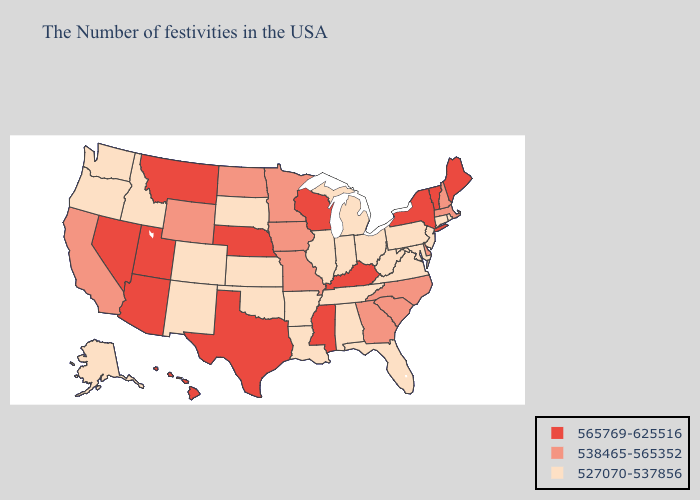What is the lowest value in states that border New Jersey?
Write a very short answer. 527070-537856. What is the highest value in states that border Florida?
Write a very short answer. 538465-565352. What is the lowest value in the South?
Answer briefly. 527070-537856. Does Georgia have the highest value in the South?
Answer briefly. No. Does Arizona have the lowest value in the West?
Write a very short answer. No. What is the value of New Jersey?
Give a very brief answer. 527070-537856. What is the value of Alabama?
Give a very brief answer. 527070-537856. What is the lowest value in the USA?
Concise answer only. 527070-537856. What is the lowest value in states that border West Virginia?
Answer briefly. 527070-537856. What is the lowest value in the West?
Keep it brief. 527070-537856. What is the value of New York?
Quick response, please. 565769-625516. Among the states that border Wisconsin , does Iowa have the highest value?
Keep it brief. Yes. Which states have the highest value in the USA?
Give a very brief answer. Maine, Vermont, New York, Kentucky, Wisconsin, Mississippi, Nebraska, Texas, Utah, Montana, Arizona, Nevada, Hawaii. What is the value of Idaho?
Keep it brief. 527070-537856. 